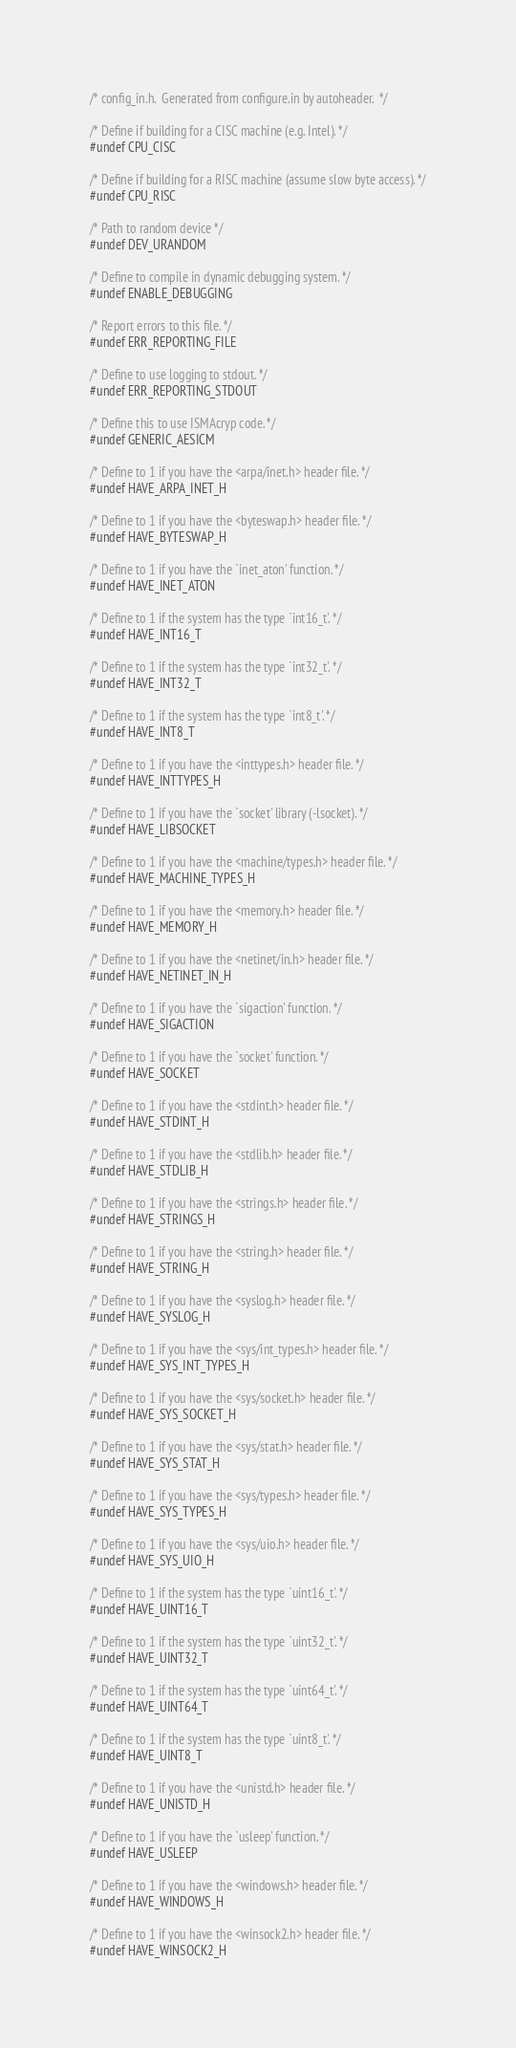Convert code to text. <code><loc_0><loc_0><loc_500><loc_500><_C_>/* config_in.h.  Generated from configure.in by autoheader.  */

/* Define if building for a CISC machine (e.g. Intel). */
#undef CPU_CISC

/* Define if building for a RISC machine (assume slow byte access). */
#undef CPU_RISC

/* Path to random device */
#undef DEV_URANDOM

/* Define to compile in dynamic debugging system. */
#undef ENABLE_DEBUGGING

/* Report errors to this file. */
#undef ERR_REPORTING_FILE

/* Define to use logging to stdout. */
#undef ERR_REPORTING_STDOUT

/* Define this to use ISMAcryp code. */
#undef GENERIC_AESICM

/* Define to 1 if you have the <arpa/inet.h> header file. */
#undef HAVE_ARPA_INET_H

/* Define to 1 if you have the <byteswap.h> header file. */
#undef HAVE_BYTESWAP_H

/* Define to 1 if you have the `inet_aton' function. */
#undef HAVE_INET_ATON

/* Define to 1 if the system has the type `int16_t'. */
#undef HAVE_INT16_T

/* Define to 1 if the system has the type `int32_t'. */
#undef HAVE_INT32_T

/* Define to 1 if the system has the type `int8_t'. */
#undef HAVE_INT8_T

/* Define to 1 if you have the <inttypes.h> header file. */
#undef HAVE_INTTYPES_H

/* Define to 1 if you have the `socket' library (-lsocket). */
#undef HAVE_LIBSOCKET

/* Define to 1 if you have the <machine/types.h> header file. */
#undef HAVE_MACHINE_TYPES_H

/* Define to 1 if you have the <memory.h> header file. */
#undef HAVE_MEMORY_H

/* Define to 1 if you have the <netinet/in.h> header file. */
#undef HAVE_NETINET_IN_H

/* Define to 1 if you have the `sigaction' function. */
#undef HAVE_SIGACTION

/* Define to 1 if you have the `socket' function. */
#undef HAVE_SOCKET

/* Define to 1 if you have the <stdint.h> header file. */
#undef HAVE_STDINT_H

/* Define to 1 if you have the <stdlib.h> header file. */
#undef HAVE_STDLIB_H

/* Define to 1 if you have the <strings.h> header file. */
#undef HAVE_STRINGS_H

/* Define to 1 if you have the <string.h> header file. */
#undef HAVE_STRING_H

/* Define to 1 if you have the <syslog.h> header file. */
#undef HAVE_SYSLOG_H

/* Define to 1 if you have the <sys/int_types.h> header file. */
#undef HAVE_SYS_INT_TYPES_H

/* Define to 1 if you have the <sys/socket.h> header file. */
#undef HAVE_SYS_SOCKET_H

/* Define to 1 if you have the <sys/stat.h> header file. */
#undef HAVE_SYS_STAT_H

/* Define to 1 if you have the <sys/types.h> header file. */
#undef HAVE_SYS_TYPES_H

/* Define to 1 if you have the <sys/uio.h> header file. */
#undef HAVE_SYS_UIO_H

/* Define to 1 if the system has the type `uint16_t'. */
#undef HAVE_UINT16_T

/* Define to 1 if the system has the type `uint32_t'. */
#undef HAVE_UINT32_T

/* Define to 1 if the system has the type `uint64_t'. */
#undef HAVE_UINT64_T

/* Define to 1 if the system has the type `uint8_t'. */
#undef HAVE_UINT8_T

/* Define to 1 if you have the <unistd.h> header file. */
#undef HAVE_UNISTD_H

/* Define to 1 if you have the `usleep' function. */
#undef HAVE_USLEEP

/* Define to 1 if you have the <windows.h> header file. */
#undef HAVE_WINDOWS_H

/* Define to 1 if you have the <winsock2.h> header file. */
#undef HAVE_WINSOCK2_H
</code> 